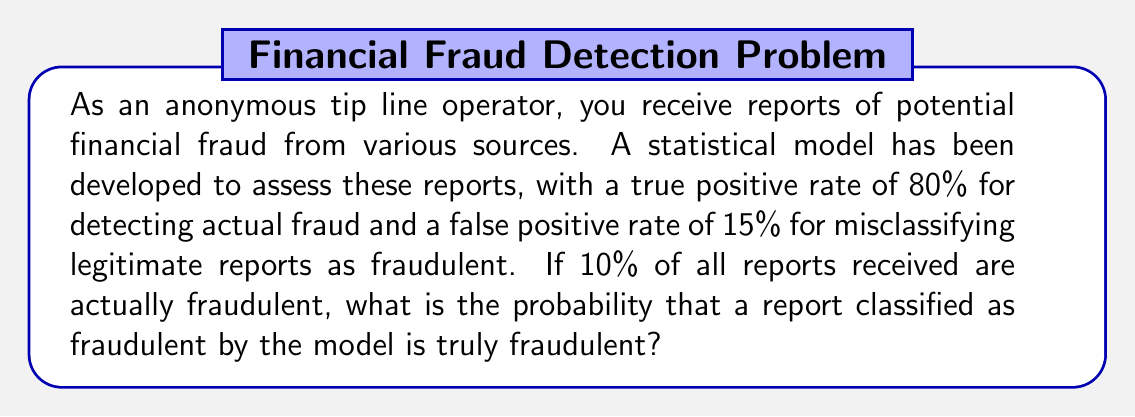Could you help me with this problem? To solve this problem, we'll use Bayes' theorem. Let's define our events:

F: The report is truly fraudulent
P: The model predicts the report is fraudulent

We're given:
P(F) = 0.10 (10% of reports are actually fraudulent)
P(P|F) = 0.80 (true positive rate)
P(P|not F) = 0.15 (false positive rate)

We want to find P(F|P), the probability that a report is truly fraudulent given that the model predicts it is fraudulent.

Bayes' theorem states:

$$ P(F|P) = \frac{P(P|F) \cdot P(F)}{P(P)} $$

We need to calculate P(P), which we can do using the law of total probability:

$$ P(P) = P(P|F) \cdot P(F) + P(P|not F) \cdot P(not F) $$

Step 1: Calculate P(not F)
P(not F) = 1 - P(F) = 1 - 0.10 = 0.90

Step 2: Calculate P(P)
$$ P(P) = 0.80 \cdot 0.10 + 0.15 \cdot 0.90 = 0.08 + 0.135 = 0.215 $$

Step 3: Apply Bayes' theorem
$$ P(F|P) = \frac{0.80 \cdot 0.10}{0.215} = \frac{0.08}{0.215} \approx 0.3721 $$

Therefore, the probability that a report classified as fraudulent by the model is truly fraudulent is approximately 0.3721 or 37.21%.
Answer: 0.3721 